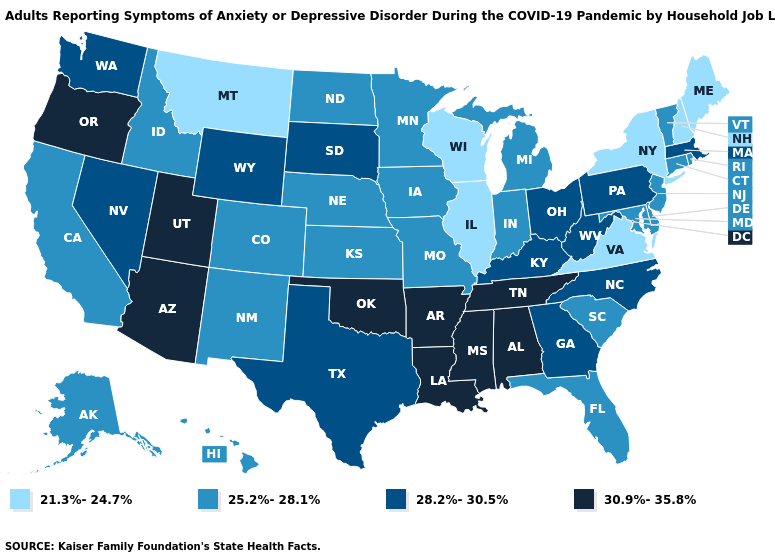Does Washington have the same value as Mississippi?
Write a very short answer. No. What is the lowest value in states that border Connecticut?
Quick response, please. 21.3%-24.7%. What is the value of Virginia?
Quick response, please. 21.3%-24.7%. What is the value of North Carolina?
Short answer required. 28.2%-30.5%. Among the states that border Michigan , does Wisconsin have the lowest value?
Give a very brief answer. Yes. Name the states that have a value in the range 25.2%-28.1%?
Quick response, please. Alaska, California, Colorado, Connecticut, Delaware, Florida, Hawaii, Idaho, Indiana, Iowa, Kansas, Maryland, Michigan, Minnesota, Missouri, Nebraska, New Jersey, New Mexico, North Dakota, Rhode Island, South Carolina, Vermont. Does Wisconsin have a lower value than Ohio?
Give a very brief answer. Yes. Which states have the lowest value in the USA?
Write a very short answer. Illinois, Maine, Montana, New Hampshire, New York, Virginia, Wisconsin. Does Louisiana have a higher value than Oklahoma?
Concise answer only. No. Does Montana have a higher value than Maryland?
Quick response, please. No. Which states have the lowest value in the USA?
Concise answer only. Illinois, Maine, Montana, New Hampshire, New York, Virginia, Wisconsin. What is the value of Arizona?
Answer briefly. 30.9%-35.8%. Does the map have missing data?
Be succinct. No. Name the states that have a value in the range 21.3%-24.7%?
Answer briefly. Illinois, Maine, Montana, New Hampshire, New York, Virginia, Wisconsin. Which states have the lowest value in the USA?
Be succinct. Illinois, Maine, Montana, New Hampshire, New York, Virginia, Wisconsin. 